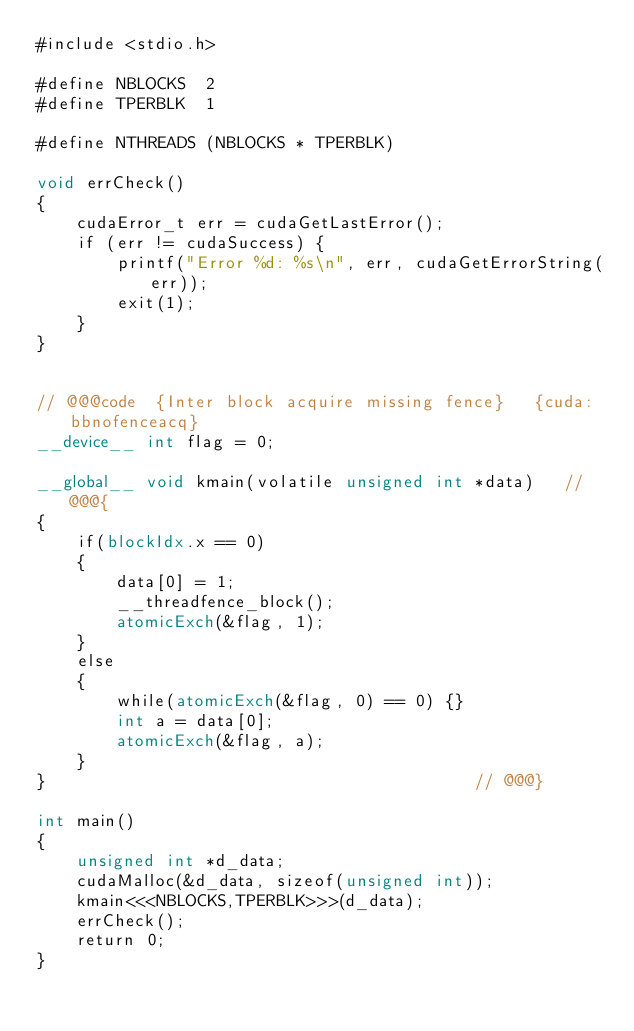<code> <loc_0><loc_0><loc_500><loc_500><_Cuda_>#include <stdio.h>

#define NBLOCKS  2
#define TPERBLK  1

#define NTHREADS (NBLOCKS * TPERBLK)

void errCheck()
{
    cudaError_t err = cudaGetLastError();
    if (err != cudaSuccess) {
        printf("Error %d: %s\n", err, cudaGetErrorString(err));
        exit(1);
    }
}


// @@@code  {Inter block acquire missing fence}   {cuda:bbnofenceacq}
__device__ int flag = 0;

__global__ void kmain(volatile unsigned int *data)   // @@@{
{
    if(blockIdx.x == 0)
    {
        data[0] = 1;
        __threadfence_block();
        atomicExch(&flag, 1);
    }
    else
    {
        while(atomicExch(&flag, 0) == 0) {}
        int a = data[0];
        atomicExch(&flag, a);
    }
}                                           // @@@}

int main() 
{
    unsigned int *d_data;
    cudaMalloc(&d_data, sizeof(unsigned int));
    kmain<<<NBLOCKS,TPERBLK>>>(d_data);
    errCheck();
    return 0;
}

</code> 